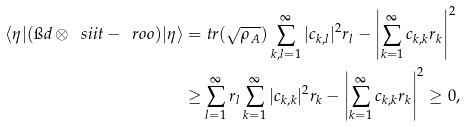Convert formula to latex. <formula><loc_0><loc_0><loc_500><loc_500>\langle \eta | ( \i d \otimes \ s i i t - \ r o o ) | \eta \rangle = & \ t r ( \sqrt { \rho _ { A } } ) \sum _ { k , l = 1 } ^ { \infty } | c _ { k , l } | ^ { 2 } r _ { l } - \left | \sum _ { k = 1 } ^ { \infty } c _ { k , k } r _ { k } \right | ^ { 2 } \\ \geq & \sum _ { l = 1 } ^ { \infty } r _ { l } \sum _ { k = 1 } ^ { \infty } | c _ { k , k } | ^ { 2 } r _ { k } - \left | \sum _ { k = 1 } ^ { \infty } c _ { k , k } r _ { k } \right | ^ { 2 } \geq 0 ,</formula> 